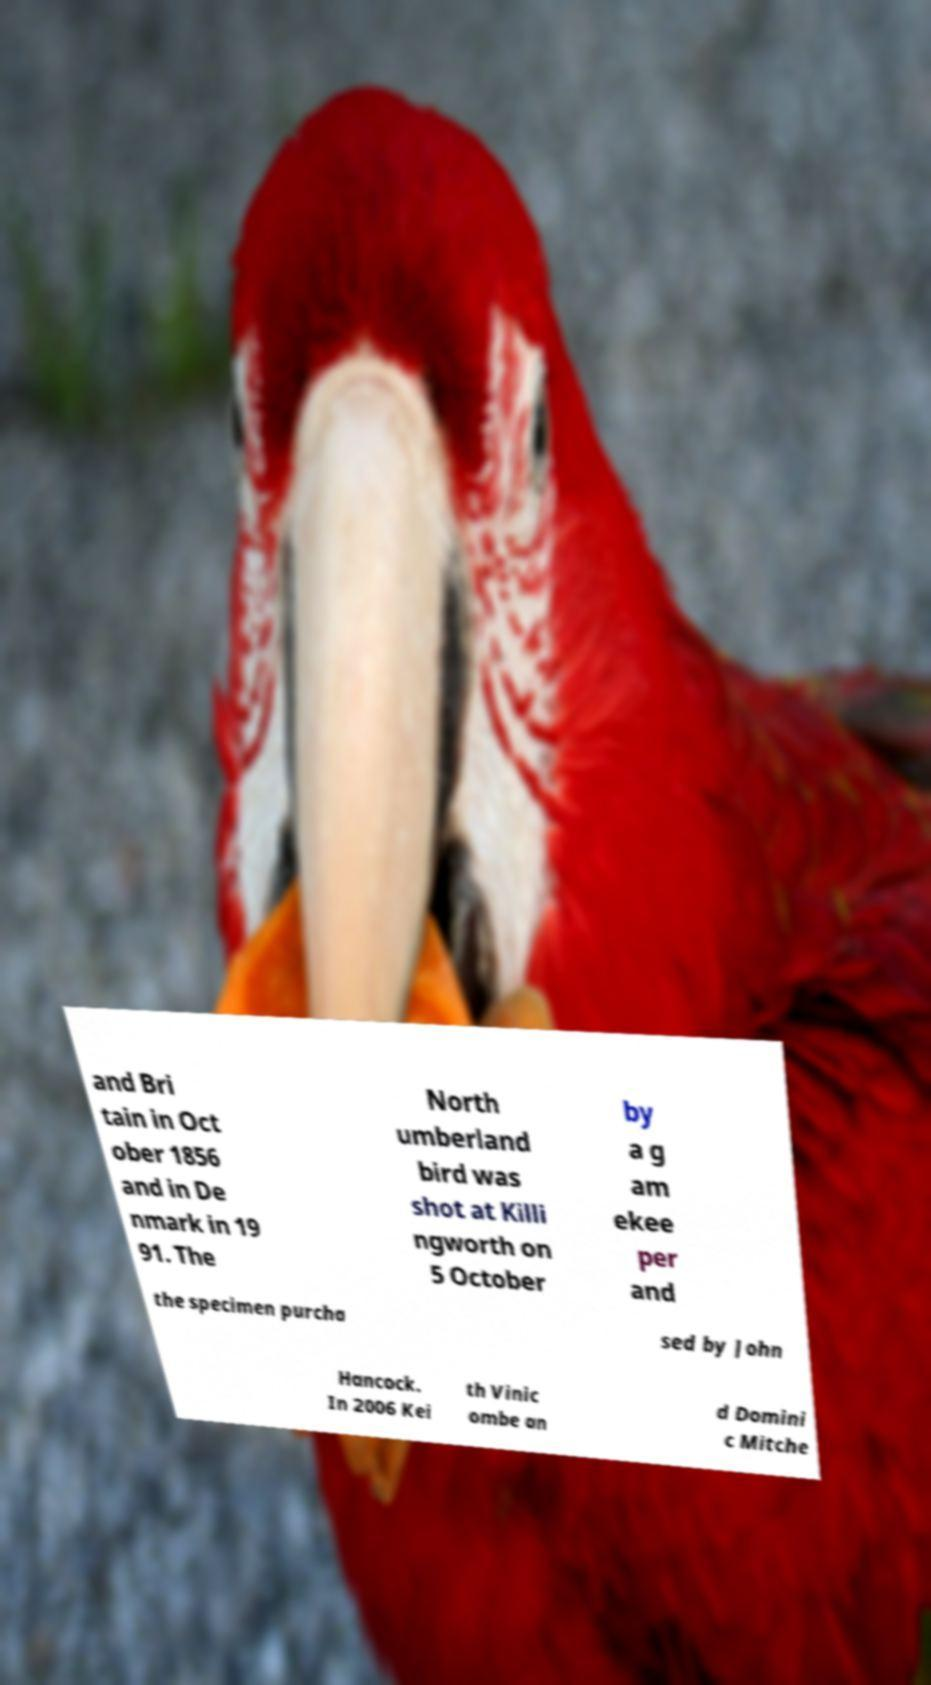Please identify and transcribe the text found in this image. and Bri tain in Oct ober 1856 and in De nmark in 19 91. The North umberland bird was shot at Killi ngworth on 5 October by a g am ekee per and the specimen purcha sed by John Hancock. In 2006 Kei th Vinic ombe an d Domini c Mitche 